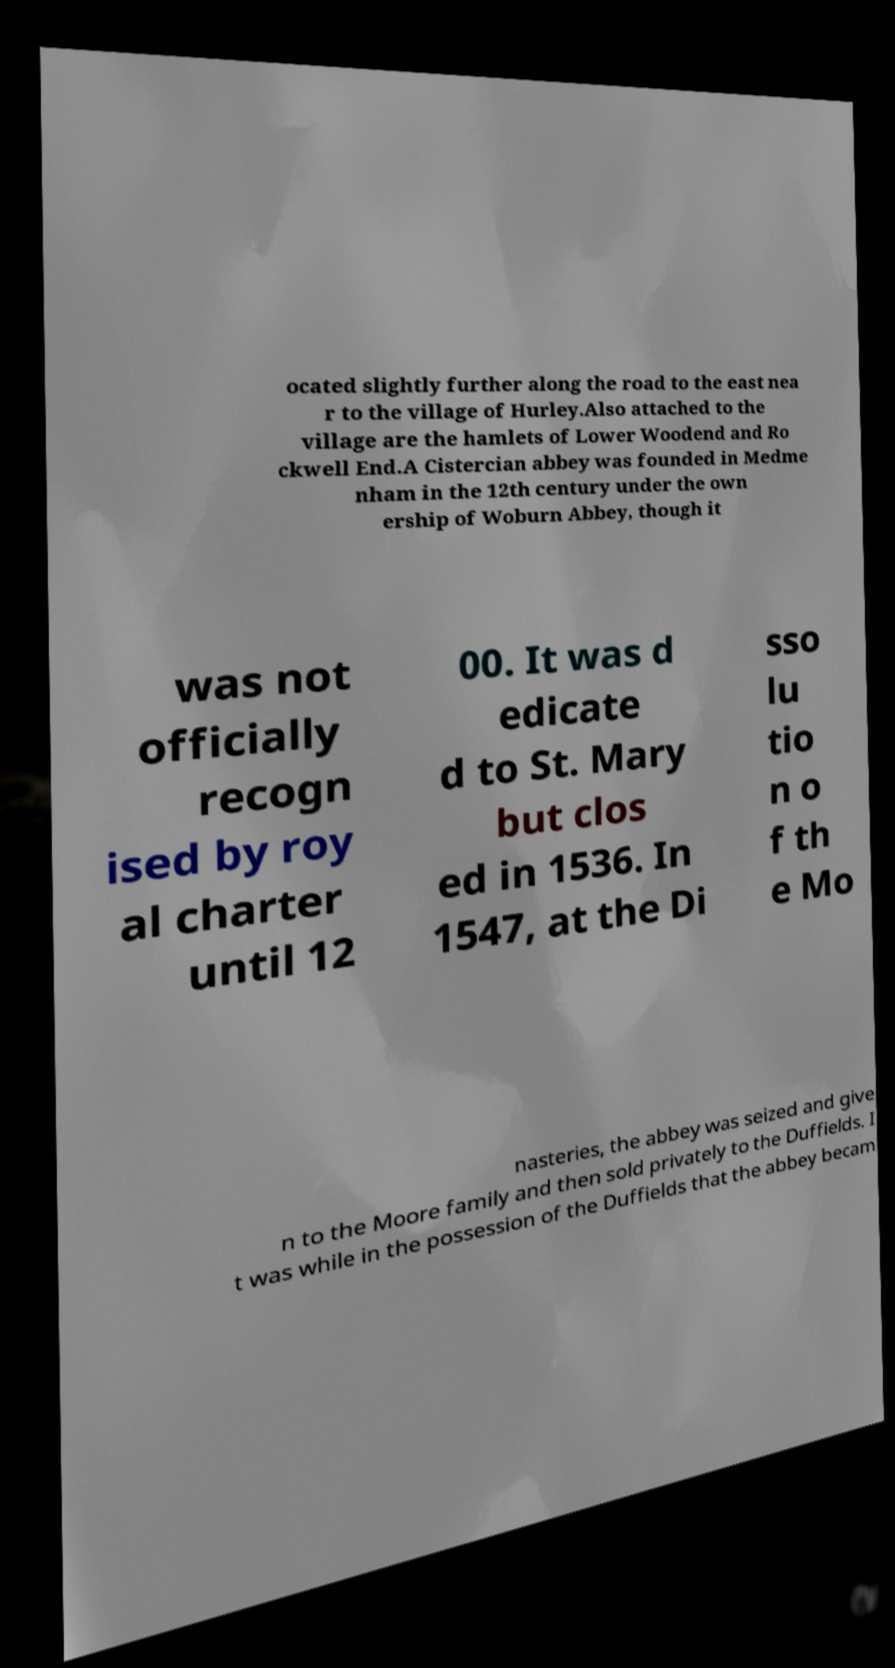There's text embedded in this image that I need extracted. Can you transcribe it verbatim? ocated slightly further along the road to the east nea r to the village of Hurley.Also attached to the village are the hamlets of Lower Woodend and Ro ckwell End.A Cistercian abbey was founded in Medme nham in the 12th century under the own ership of Woburn Abbey, though it was not officially recogn ised by roy al charter until 12 00. It was d edicate d to St. Mary but clos ed in 1536. In 1547, at the Di sso lu tio n o f th e Mo nasteries, the abbey was seized and give n to the Moore family and then sold privately to the Duffields. I t was while in the possession of the Duffields that the abbey becam 